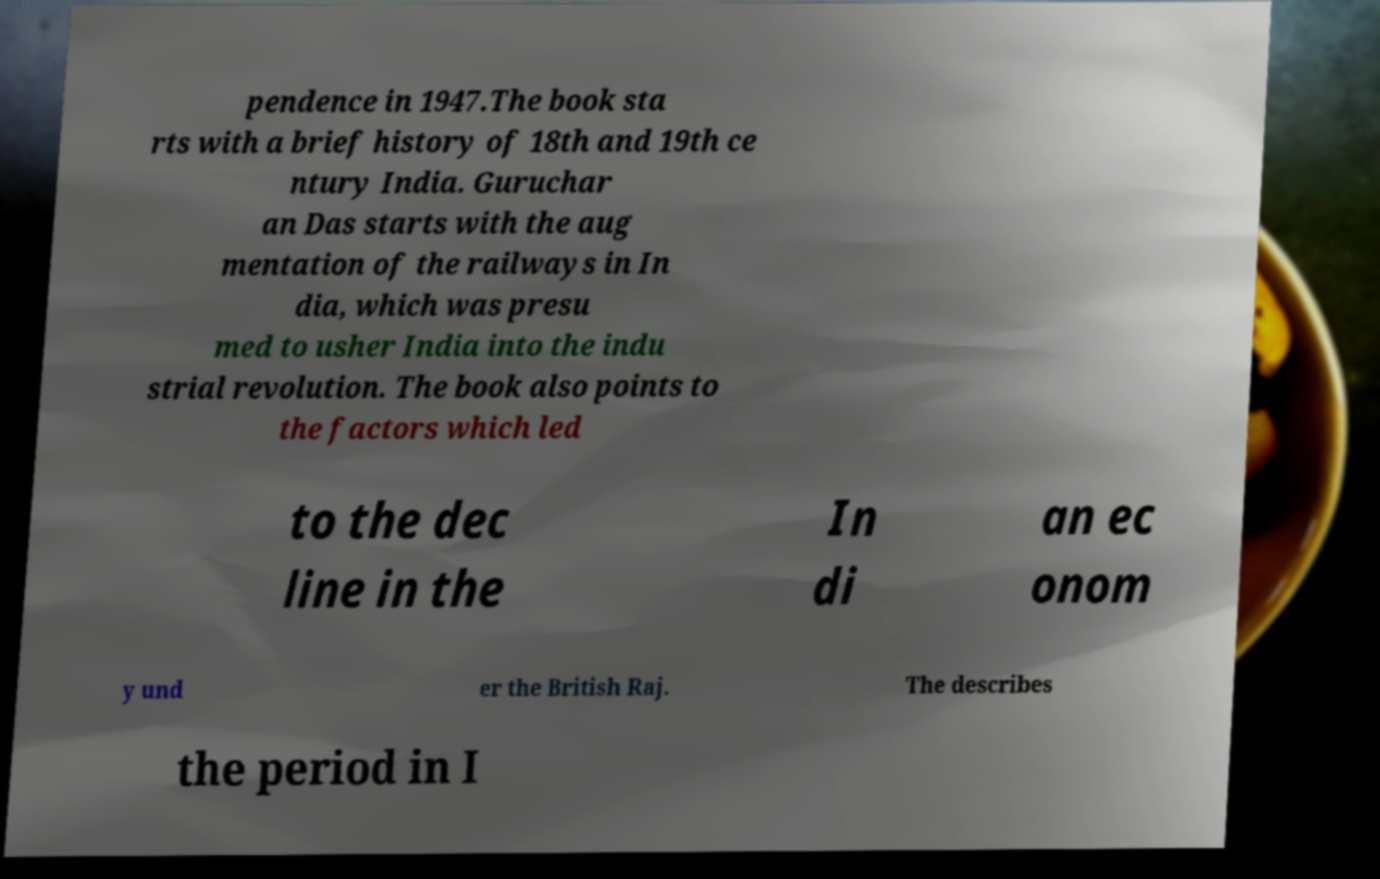Please read and relay the text visible in this image. What does it say? pendence in 1947.The book sta rts with a brief history of 18th and 19th ce ntury India. Guruchar an Das starts with the aug mentation of the railways in In dia, which was presu med to usher India into the indu strial revolution. The book also points to the factors which led to the dec line in the In di an ec onom y und er the British Raj. The describes the period in I 